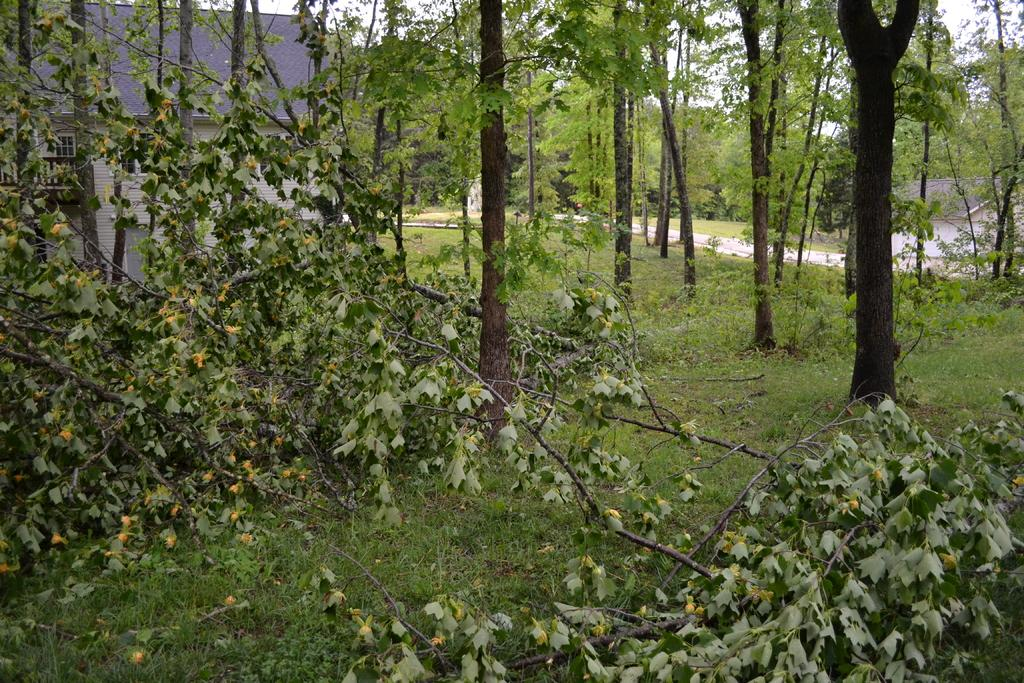What type of vegetation is present in the image? There are many trees in the image. What is the color of the grass at the bottom of the image? The grass at the bottom of the image is green. Where is the small house located in the image? The small house is to the left of the image. What type of humor can be found in the image? There is no humor present in the image; it is a scene of trees, grass, and a small house. What time of day is depicted in the image? The provided facts do not give any information about the time of day, so it cannot be determined from the image. 